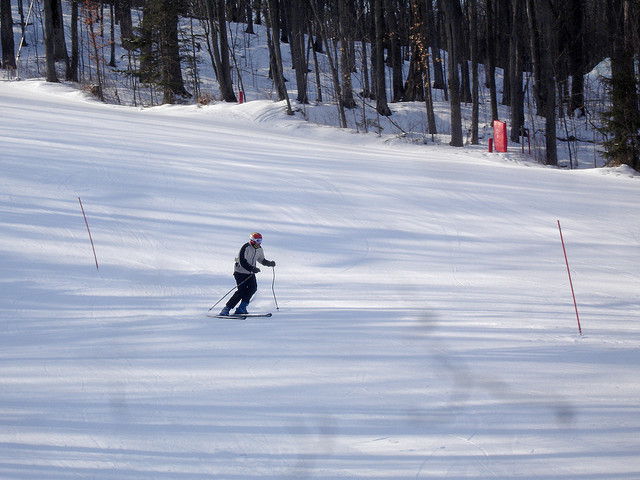<image>Why are there sticks in the snow? It is not sure why there are sticks in the snow. They could be there for a variety of reasons such as race markers, to guide skiers, or to mark ski trails. Why are there sticks in the snow? I don't know why there are sticks in the snow. It can be for race markers, to mark ski trails, or to guide skiers. 